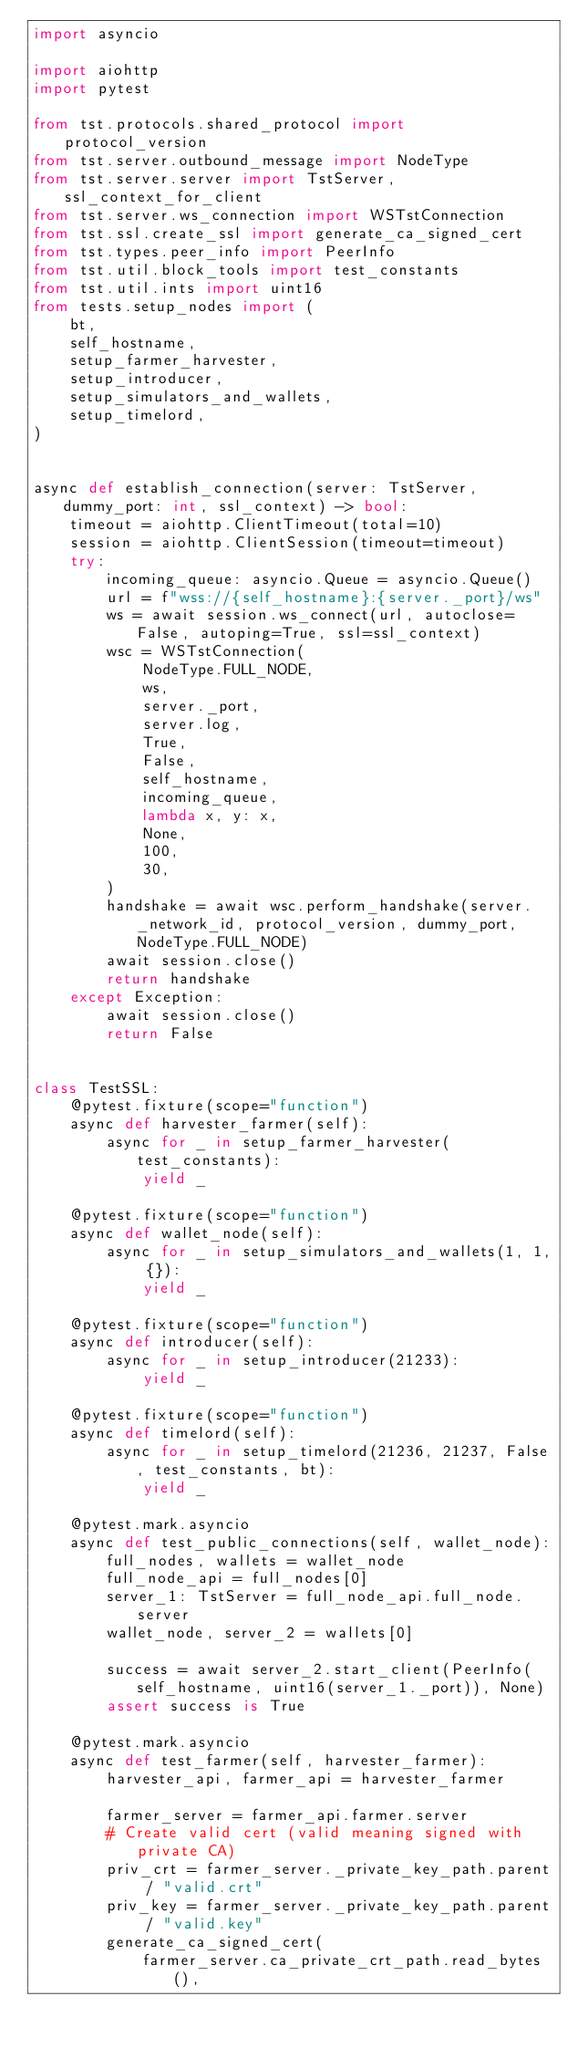<code> <loc_0><loc_0><loc_500><loc_500><_Python_>import asyncio

import aiohttp
import pytest

from tst.protocols.shared_protocol import protocol_version
from tst.server.outbound_message import NodeType
from tst.server.server import TstServer, ssl_context_for_client
from tst.server.ws_connection import WSTstConnection
from tst.ssl.create_ssl import generate_ca_signed_cert
from tst.types.peer_info import PeerInfo
from tst.util.block_tools import test_constants
from tst.util.ints import uint16
from tests.setup_nodes import (
    bt,
    self_hostname,
    setup_farmer_harvester,
    setup_introducer,
    setup_simulators_and_wallets,
    setup_timelord,
)


async def establish_connection(server: TstServer, dummy_port: int, ssl_context) -> bool:
    timeout = aiohttp.ClientTimeout(total=10)
    session = aiohttp.ClientSession(timeout=timeout)
    try:
        incoming_queue: asyncio.Queue = asyncio.Queue()
        url = f"wss://{self_hostname}:{server._port}/ws"
        ws = await session.ws_connect(url, autoclose=False, autoping=True, ssl=ssl_context)
        wsc = WSTstConnection(
            NodeType.FULL_NODE,
            ws,
            server._port,
            server.log,
            True,
            False,
            self_hostname,
            incoming_queue,
            lambda x, y: x,
            None,
            100,
            30,
        )
        handshake = await wsc.perform_handshake(server._network_id, protocol_version, dummy_port, NodeType.FULL_NODE)
        await session.close()
        return handshake
    except Exception:
        await session.close()
        return False


class TestSSL:
    @pytest.fixture(scope="function")
    async def harvester_farmer(self):
        async for _ in setup_farmer_harvester(test_constants):
            yield _

    @pytest.fixture(scope="function")
    async def wallet_node(self):
        async for _ in setup_simulators_and_wallets(1, 1, {}):
            yield _

    @pytest.fixture(scope="function")
    async def introducer(self):
        async for _ in setup_introducer(21233):
            yield _

    @pytest.fixture(scope="function")
    async def timelord(self):
        async for _ in setup_timelord(21236, 21237, False, test_constants, bt):
            yield _

    @pytest.mark.asyncio
    async def test_public_connections(self, wallet_node):
        full_nodes, wallets = wallet_node
        full_node_api = full_nodes[0]
        server_1: TstServer = full_node_api.full_node.server
        wallet_node, server_2 = wallets[0]

        success = await server_2.start_client(PeerInfo(self_hostname, uint16(server_1._port)), None)
        assert success is True

    @pytest.mark.asyncio
    async def test_farmer(self, harvester_farmer):
        harvester_api, farmer_api = harvester_farmer

        farmer_server = farmer_api.farmer.server
        # Create valid cert (valid meaning signed with private CA)
        priv_crt = farmer_server._private_key_path.parent / "valid.crt"
        priv_key = farmer_server._private_key_path.parent / "valid.key"
        generate_ca_signed_cert(
            farmer_server.ca_private_crt_path.read_bytes(),</code> 